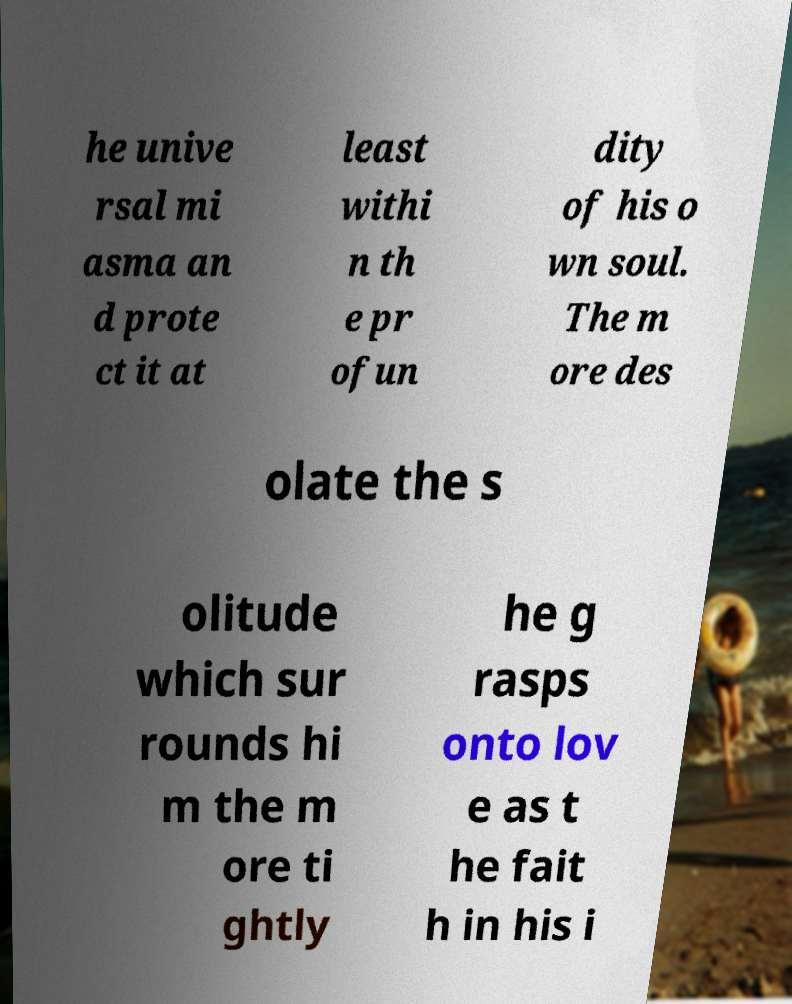Could you assist in decoding the text presented in this image and type it out clearly? he unive rsal mi asma an d prote ct it at least withi n th e pr ofun dity of his o wn soul. The m ore des olate the s olitude which sur rounds hi m the m ore ti ghtly he g rasps onto lov e as t he fait h in his i 